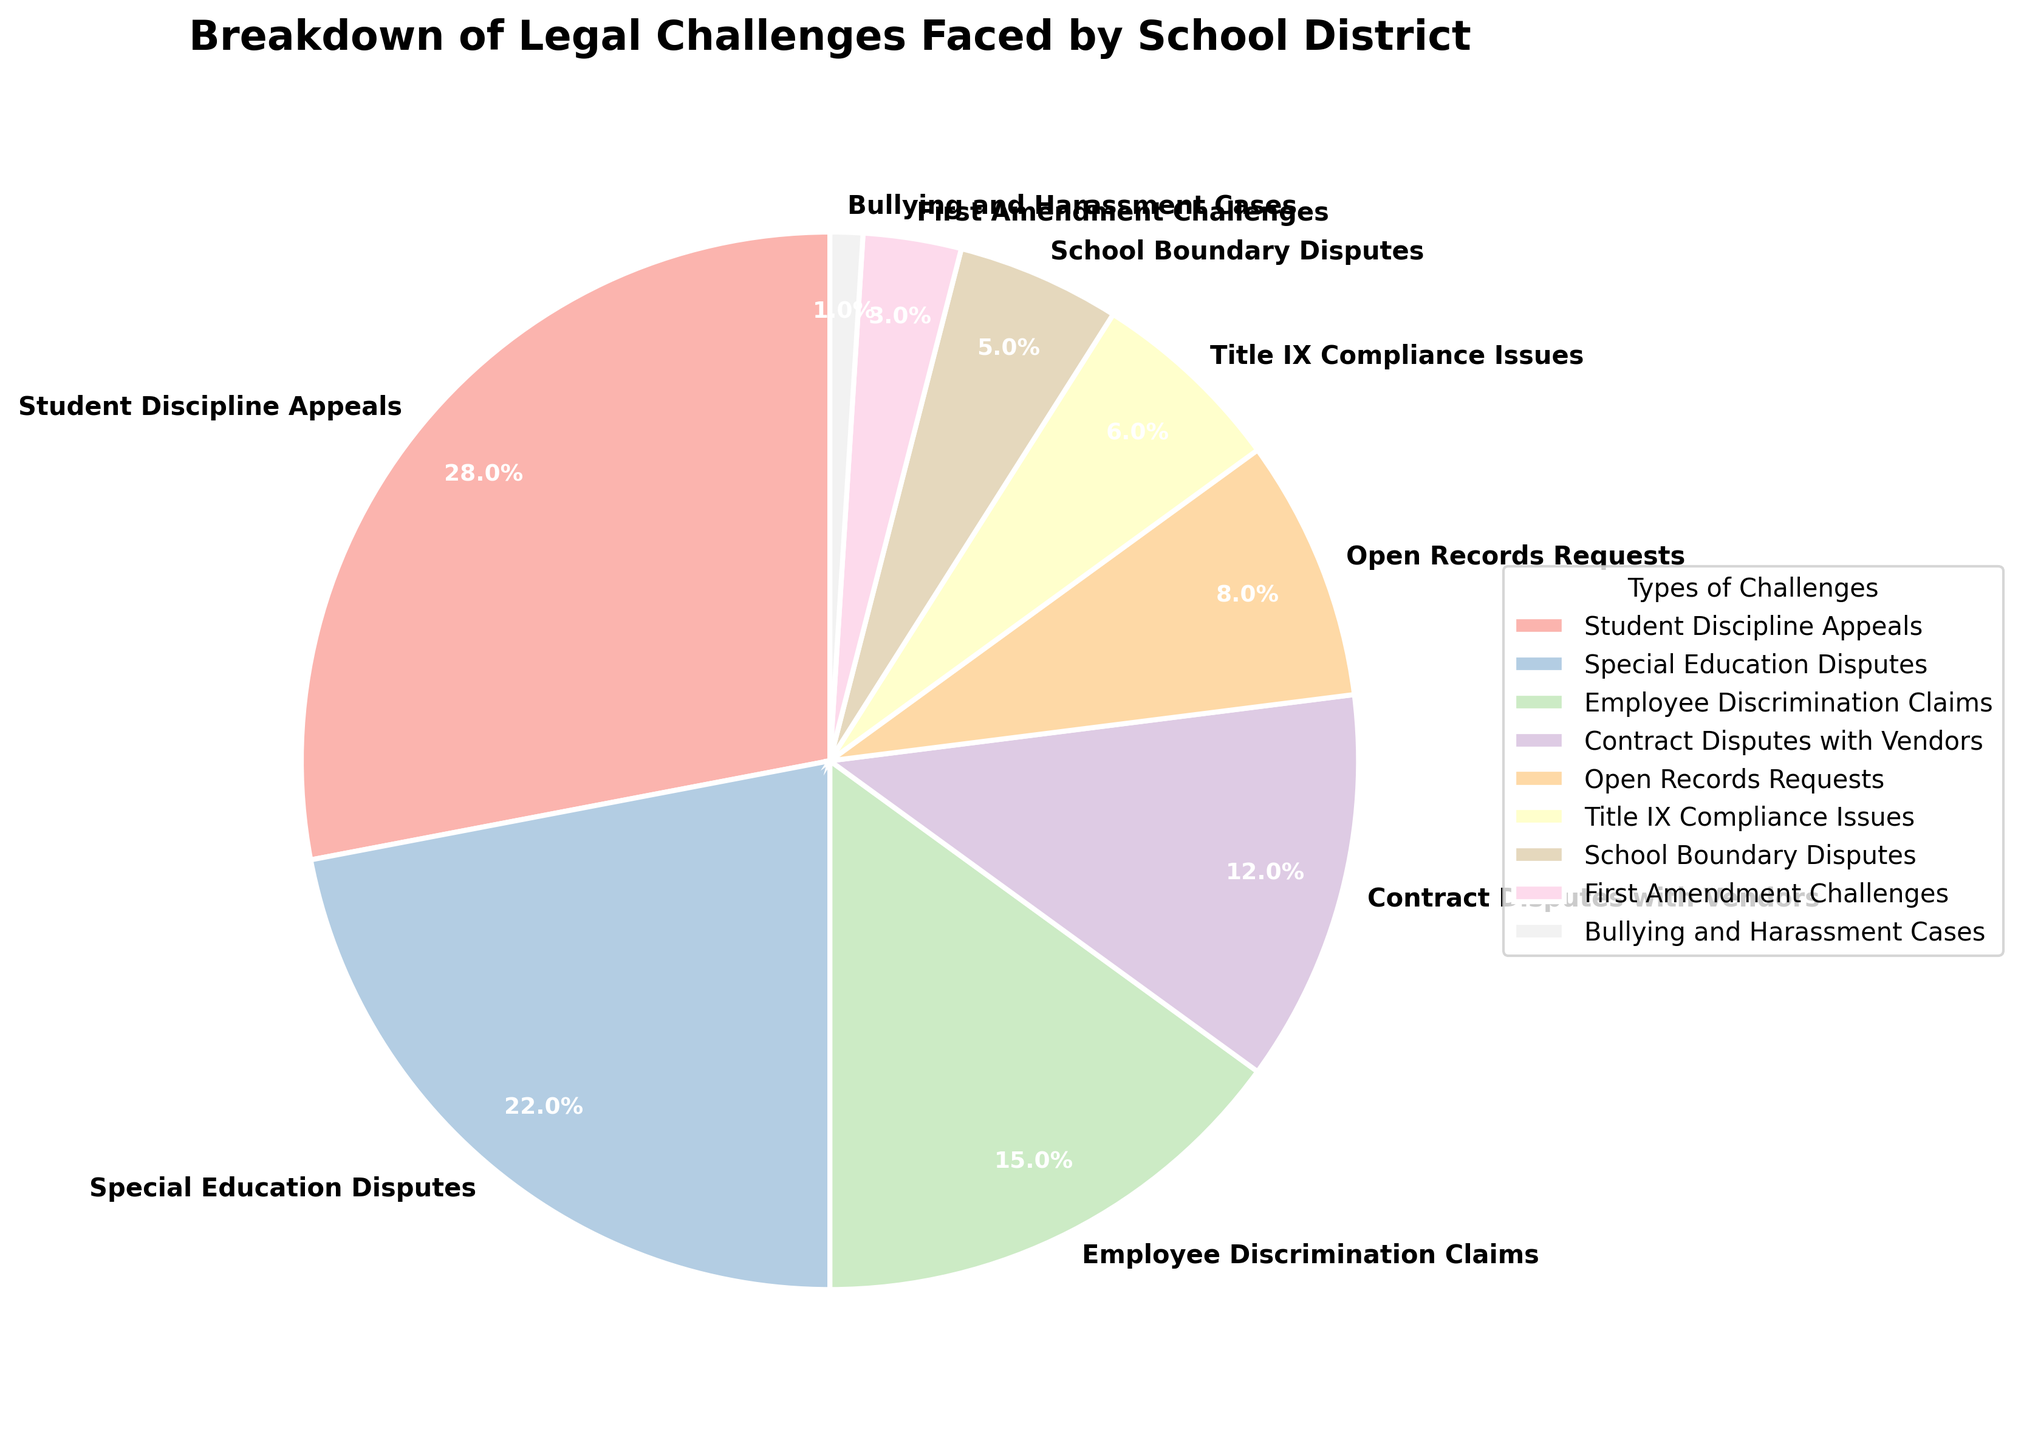Which type of legal challenge is the most common? The segment labeled "Student Discipline Appeals" has the largest size and is 28% of the total, making it the most common.
Answer: Student Discipline Appeals What is the combined percentage of Special Education Disputes and Employee Discrimination Claims? The figure shows 22% for Special Education Disputes and 15% for Employee Discrimination Claims. Adding them gives 22 + 15 = 37%.
Answer: 37% Which type of legal challenge has the smallest percentage? The segment labeled "Bullying and Harassment Cases" is the smallest and is 1% of the total.
Answer: Bullying and Harassment Cases How much greater is the percentage of Student Discipline Appeals compared to Title IX Compliance Issues? Student Discipline Appeals is 28% and Title IX Compliance Issues is 6%. The difference is 28 - 6 = 22%.
Answer: 22% If we add the percentages of Open Records Requests, Title IX Compliance Issues, and School Boundary Disputes, what do we get? The percentages are 8% for Open Records Requests, 6% for Title IX Compliance Issues, and 5% for School Boundary Disputes. Adding them gives 8 + 6 + 5 = 19%.
Answer: 19% Which type of legal challenge has a percentage twice that of School Boundary Disputes? School Boundary Disputes are 5%. Employee Discrimination Claims are 15%, which is twice the percentage of School Boundary Disputes.
Answer: Employee Discrimination Claims Is the percentage of Contract Disputes with Vendors greater than Open Records Requests and First Amendment Challenges combined? The figure shows 12% for Contract Disputes with Vendors, 8% for Open Records Requests, and 3% for First Amendment Challenges. Adding Open Records Requests and First Amendment Challenges gives 8 + 3 = 11%. Since 12% > 11%, the answer is yes.
Answer: Yes What is the total percentage of challenges under 10%? The categories under 10% are Open Records Requests (8%), Title IX Compliance Issues (6%), School Boundary Disputes (5%), First Amendment Challenges (3%), and Bullying and Harassment Cases (1%). Adding these gives 8 + 6 + 5 + 3 + 1 = 23%.
Answer: 23% 